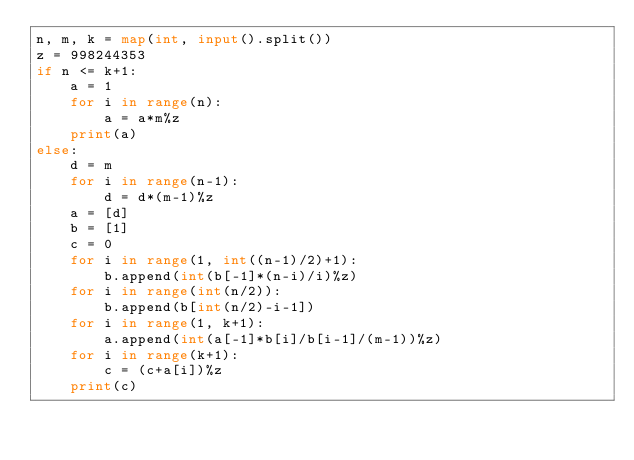<code> <loc_0><loc_0><loc_500><loc_500><_Python_>n, m, k = map(int, input().split())
z = 998244353
if n <= k+1:
    a = 1
    for i in range(n):
        a = a*m%z
    print(a)
else:
    d = m
    for i in range(n-1):
        d = d*(m-1)%z
    a = [d]
    b = [1]
    c = 0
    for i in range(1, int((n-1)/2)+1):
        b.append(int(b[-1]*(n-i)/i)%z)
    for i in range(int(n/2)):
        b.append(b[int(n/2)-i-1])
    for i in range(1, k+1):
        a.append(int(a[-1]*b[i]/b[i-1]/(m-1))%z)
    for i in range(k+1):
        c = (c+a[i])%z
    print(c)</code> 